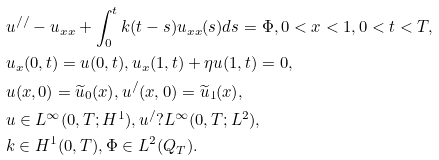Convert formula to latex. <formula><loc_0><loc_0><loc_500><loc_500>& u ^ { / / } - u _ { x x } + \int _ { 0 } ^ { t } k ( t - s ) u _ { x x } ( s ) d s = \Phi , 0 < x < 1 , 0 < t < T , \\ & u _ { x } ( 0 , t ) = u ( 0 , t ) , u _ { x } ( 1 , t ) + \eta u ( 1 , t ) = 0 , \\ & u ( x , 0 ) = \widetilde { u } _ { 0 } ( x ) , u ^ { / } ( x , 0 ) = \widetilde { u } _ { 1 } ( x ) , \\ & u \in L ^ { \infty } ( 0 , T ; H ^ { 1 } ) , u ^ { / } ? L ^ { \infty } ( 0 , T ; L ^ { 2 } ) , \\ & k \in H ^ { 1 } ( 0 , T ) , \Phi \in L ^ { 2 } ( Q _ { T } ) .</formula> 